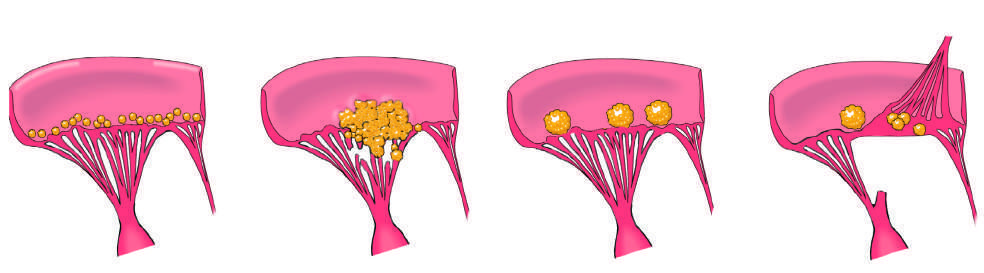s homogeneous or diffuse staining of nuclei characterized by small - to medium-sized inflammatory vegetations that can be attached on either side of the valve leaflets?
Answer the question using a single word or phrase. No 